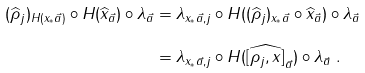Convert formula to latex. <formula><loc_0><loc_0><loc_500><loc_500>( \widehat { \rho } _ { j } ) _ { H ( x _ { \ast } \vec { a } ) } \circ H ( \widehat { x } _ { \vec { a } } ) \circ \lambda _ { \vec { a } } & = \lambda _ { x _ { \ast } \vec { a } , j } \circ H ( ( \widehat { \rho } _ { j } ) _ { x _ { \ast } \vec { a } } \circ \widehat { x } _ { \vec { a } } ) \circ \lambda _ { \vec { a } } \\ & = \lambda _ { x _ { \ast } \vec { a } , j } \circ H ( \widehat { [ \rho _ { j } , x ] } _ { \vec { a } } ) \circ \lambda _ { \vec { a } } \ .</formula> 